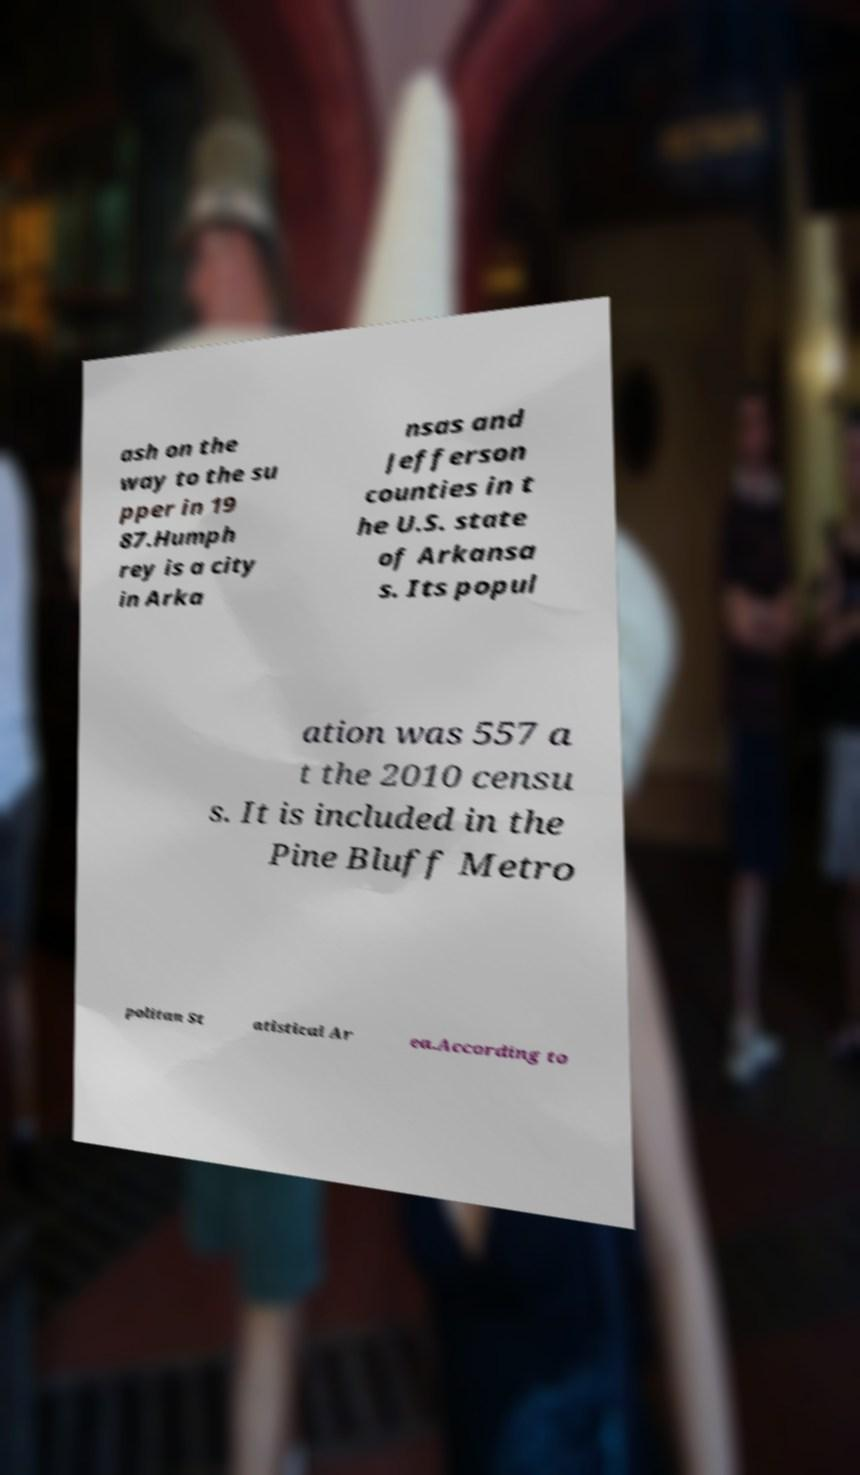Can you read and provide the text displayed in the image?This photo seems to have some interesting text. Can you extract and type it out for me? ash on the way to the su pper in 19 87.Humph rey is a city in Arka nsas and Jefferson counties in t he U.S. state of Arkansa s. Its popul ation was 557 a t the 2010 censu s. It is included in the Pine Bluff Metro politan St atistical Ar ea.According to 